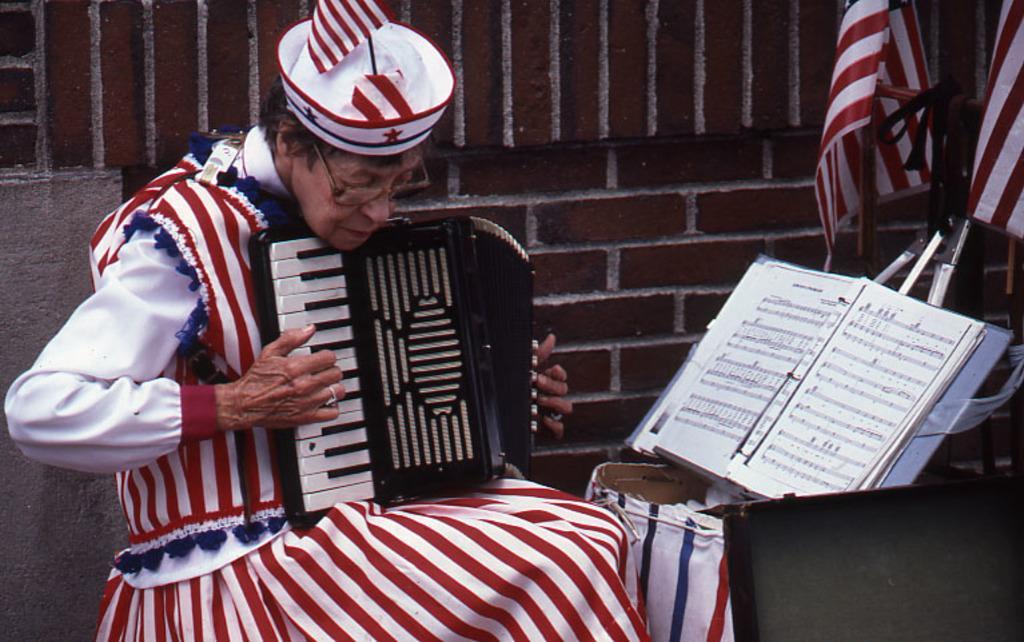In one or two sentences, can you explain what this image depicts? In this image I can see the person sitting and playing the musical instrument and the person is wearing white and red color dress. In front I can see the book. Background I can see few flags and the wall is in brown color. 